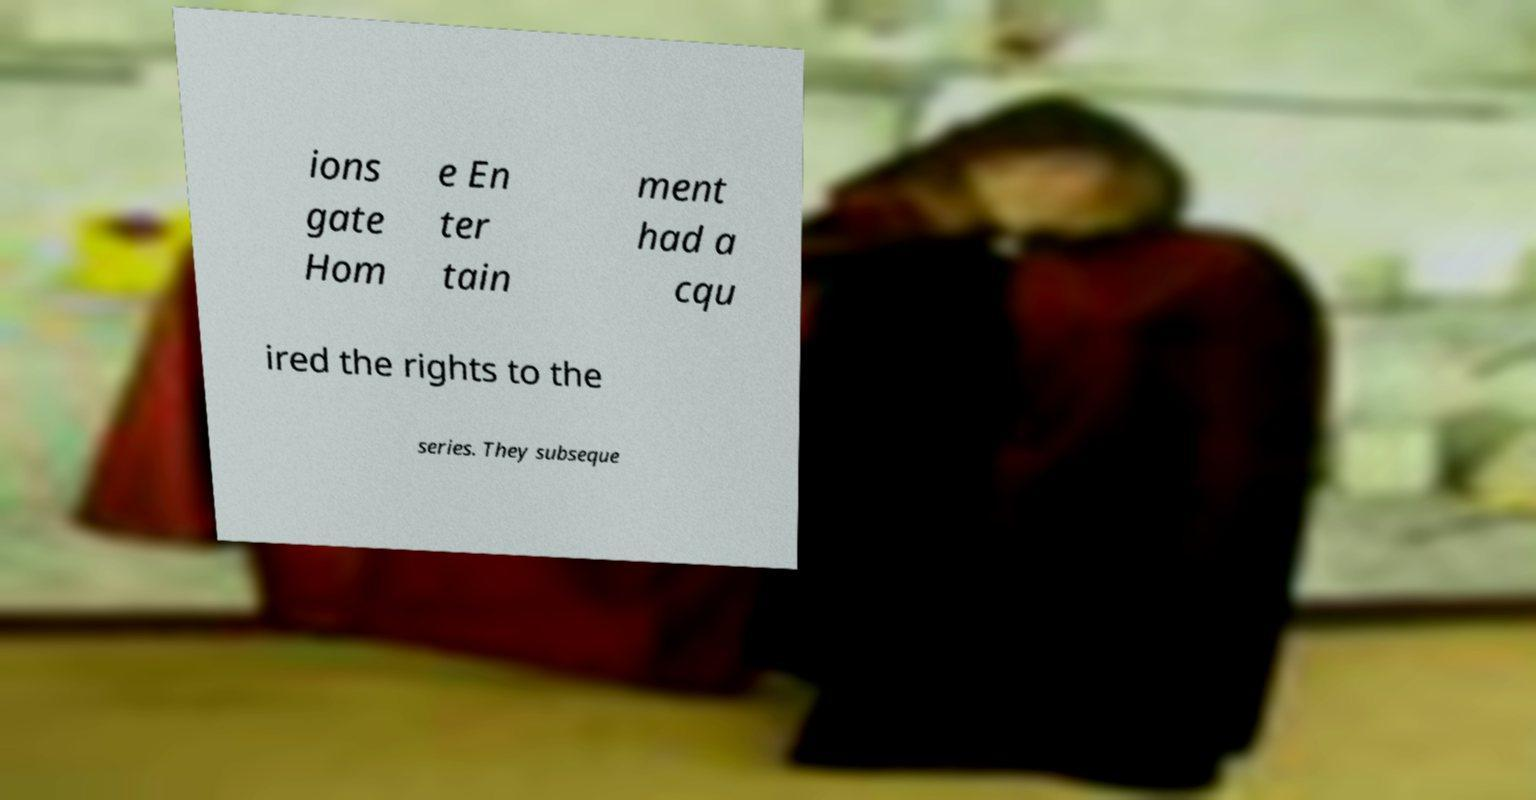There's text embedded in this image that I need extracted. Can you transcribe it verbatim? ions gate Hom e En ter tain ment had a cqu ired the rights to the series. They subseque 